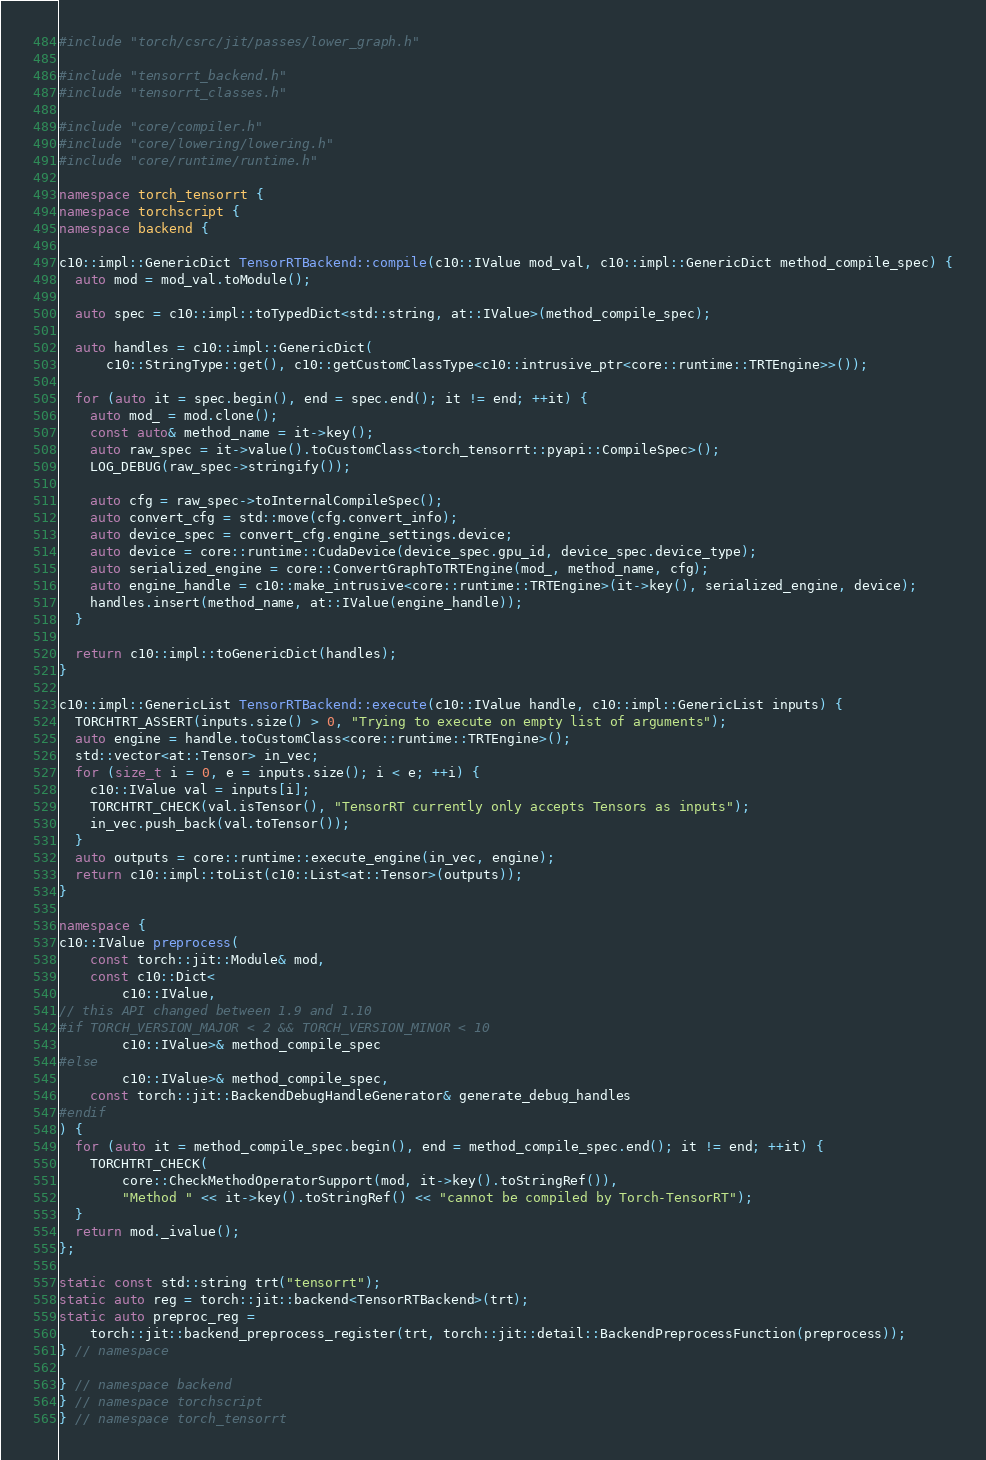Convert code to text. <code><loc_0><loc_0><loc_500><loc_500><_C++_>#include "torch/csrc/jit/passes/lower_graph.h"

#include "tensorrt_backend.h"
#include "tensorrt_classes.h"

#include "core/compiler.h"
#include "core/lowering/lowering.h"
#include "core/runtime/runtime.h"

namespace torch_tensorrt {
namespace torchscript {
namespace backend {

c10::impl::GenericDict TensorRTBackend::compile(c10::IValue mod_val, c10::impl::GenericDict method_compile_spec) {
  auto mod = mod_val.toModule();

  auto spec = c10::impl::toTypedDict<std::string, at::IValue>(method_compile_spec);

  auto handles = c10::impl::GenericDict(
      c10::StringType::get(), c10::getCustomClassType<c10::intrusive_ptr<core::runtime::TRTEngine>>());

  for (auto it = spec.begin(), end = spec.end(); it != end; ++it) {
    auto mod_ = mod.clone();
    const auto& method_name = it->key();
    auto raw_spec = it->value().toCustomClass<torch_tensorrt::pyapi::CompileSpec>();
    LOG_DEBUG(raw_spec->stringify());

    auto cfg = raw_spec->toInternalCompileSpec();
    auto convert_cfg = std::move(cfg.convert_info);
    auto device_spec = convert_cfg.engine_settings.device;
    auto device = core::runtime::CudaDevice(device_spec.gpu_id, device_spec.device_type);
    auto serialized_engine = core::ConvertGraphToTRTEngine(mod_, method_name, cfg);
    auto engine_handle = c10::make_intrusive<core::runtime::TRTEngine>(it->key(), serialized_engine, device);
    handles.insert(method_name, at::IValue(engine_handle));
  }

  return c10::impl::toGenericDict(handles);
}

c10::impl::GenericList TensorRTBackend::execute(c10::IValue handle, c10::impl::GenericList inputs) {
  TORCHTRT_ASSERT(inputs.size() > 0, "Trying to execute on empty list of arguments");
  auto engine = handle.toCustomClass<core::runtime::TRTEngine>();
  std::vector<at::Tensor> in_vec;
  for (size_t i = 0, e = inputs.size(); i < e; ++i) {
    c10::IValue val = inputs[i];
    TORCHTRT_CHECK(val.isTensor(), "TensorRT currently only accepts Tensors as inputs");
    in_vec.push_back(val.toTensor());
  }
  auto outputs = core::runtime::execute_engine(in_vec, engine);
  return c10::impl::toList(c10::List<at::Tensor>(outputs));
}

namespace {
c10::IValue preprocess(
    const torch::jit::Module& mod,
    const c10::Dict<
        c10::IValue,
// this API changed between 1.9 and 1.10
#if TORCH_VERSION_MAJOR < 2 && TORCH_VERSION_MINOR < 10
        c10::IValue>& method_compile_spec
#else
        c10::IValue>& method_compile_spec,
    const torch::jit::BackendDebugHandleGenerator& generate_debug_handles
#endif
) {
  for (auto it = method_compile_spec.begin(), end = method_compile_spec.end(); it != end; ++it) {
    TORCHTRT_CHECK(
        core::CheckMethodOperatorSupport(mod, it->key().toStringRef()),
        "Method " << it->key().toStringRef() << "cannot be compiled by Torch-TensorRT");
  }
  return mod._ivalue();
};

static const std::string trt("tensorrt");
static auto reg = torch::jit::backend<TensorRTBackend>(trt);
static auto preproc_reg =
    torch::jit::backend_preprocess_register(trt, torch::jit::detail::BackendPreprocessFunction(preprocess));
} // namespace

} // namespace backend
} // namespace torchscript
} // namespace torch_tensorrt
</code> 